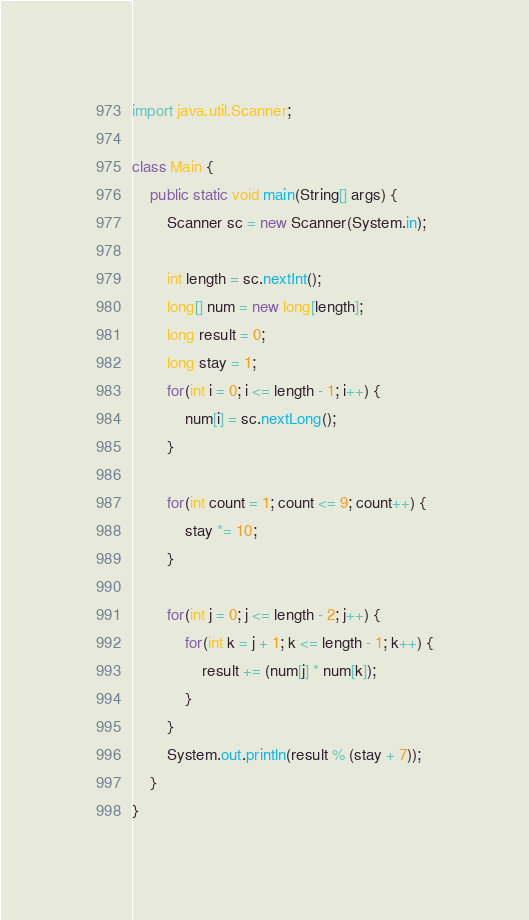Convert code to text. <code><loc_0><loc_0><loc_500><loc_500><_Java_>import java.util.Scanner;

class Main {
	public static void main(String[] args) {
    	Scanner sc = new Scanner(System.in);
      
      	int length = sc.nextInt();
      	long[] num = new long[length];
      	long result = 0;
      	long stay = 1;
		for(int i = 0; i <= length - 1; i++) {
        	num[i] = sc.nextLong();
        }
      
      	for(int count = 1; count <= 9; count++) {
        	stay *= 10;
        }
      
      	for(int j = 0; j <= length - 2; j++) {
        	for(int k = j + 1; k <= length - 1; k++) {
            	result += (num[j] * num[k]);
            }
        }
		System.out.println(result % (stay + 7));
    }
}</code> 